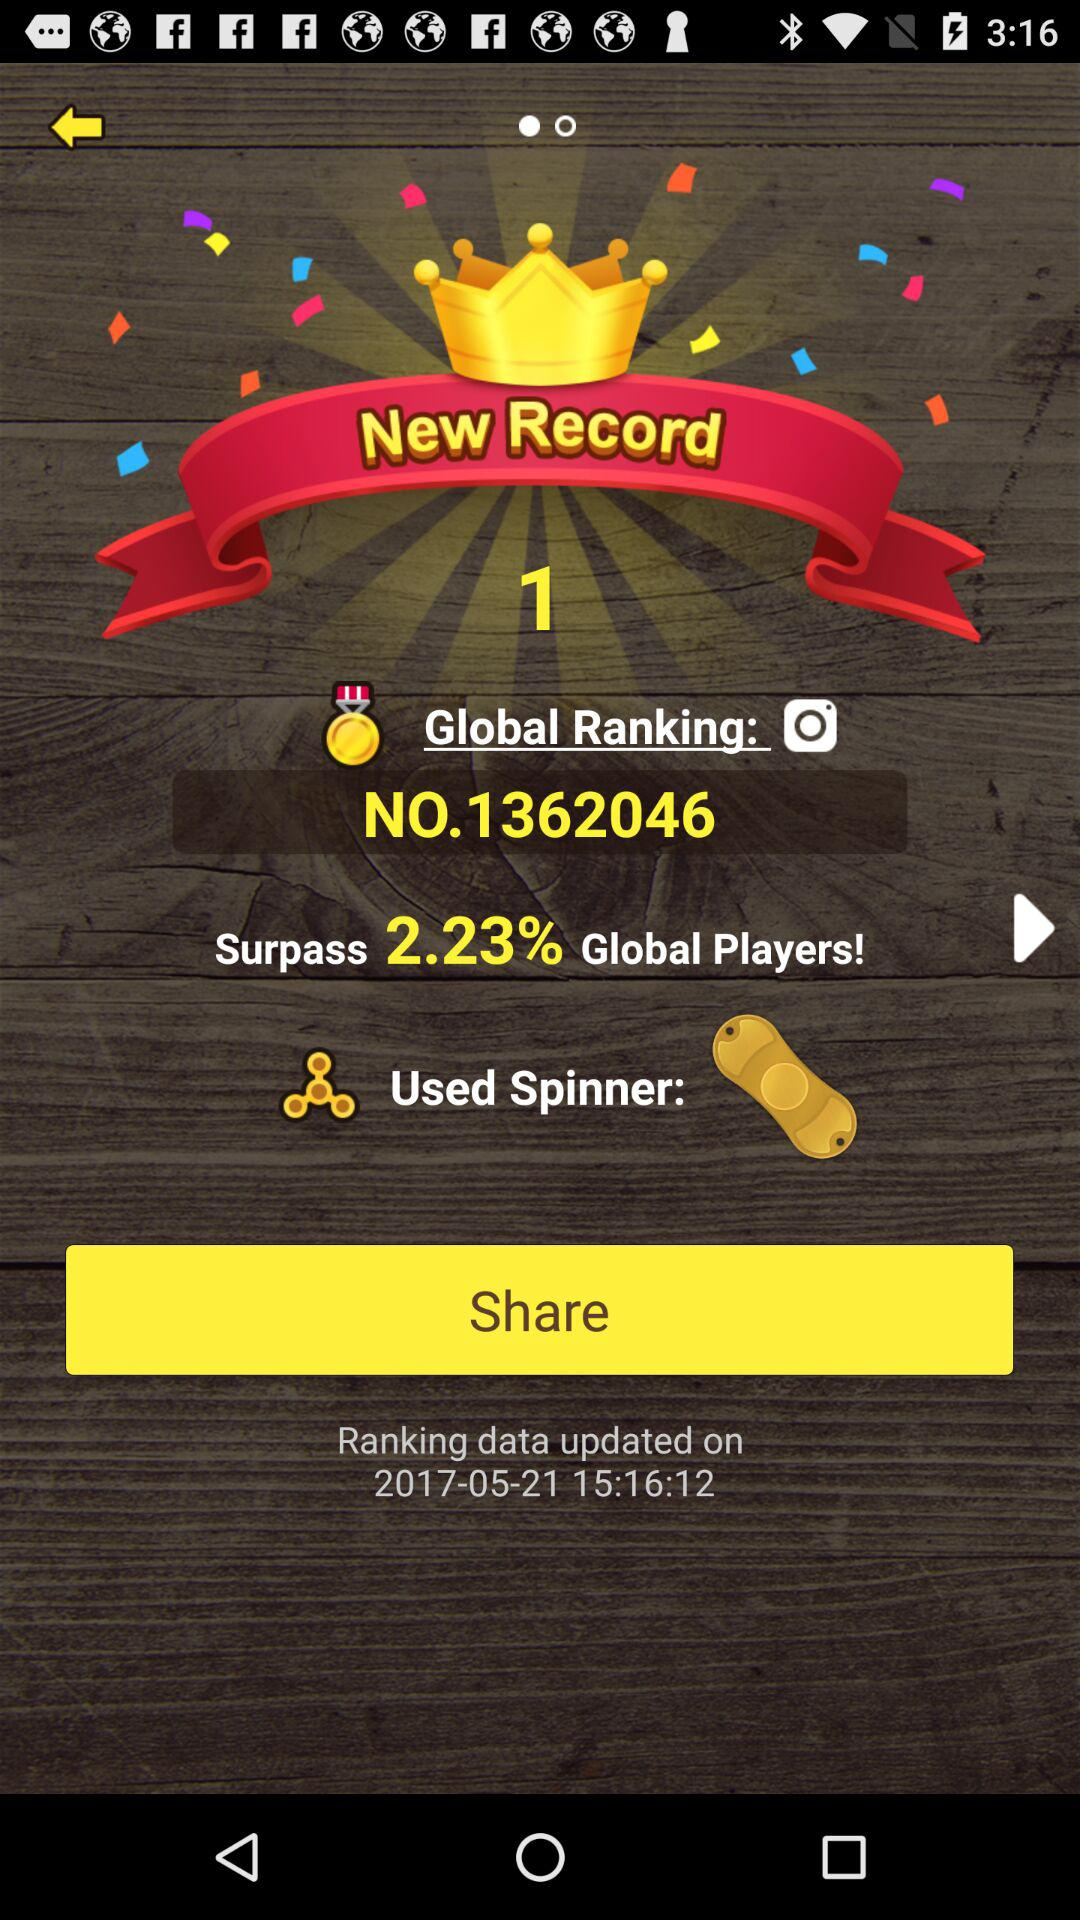On which date was the ranking data updated? The ranking data was updated on May 21, 2017. 